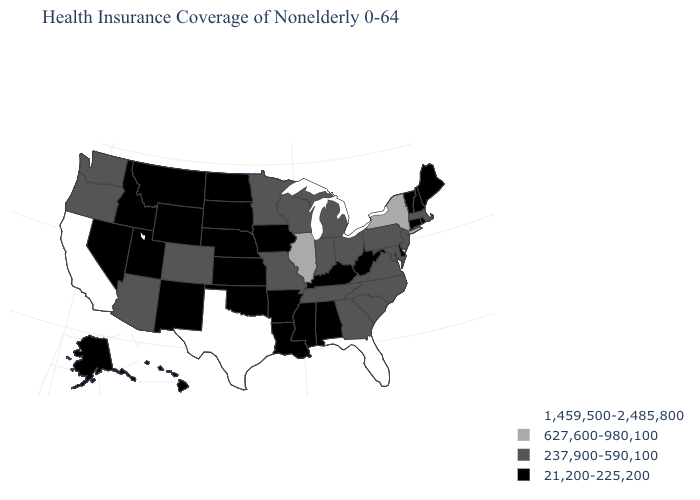Name the states that have a value in the range 237,900-590,100?
Answer briefly. Arizona, Colorado, Georgia, Indiana, Maryland, Massachusetts, Michigan, Minnesota, Missouri, New Jersey, North Carolina, Ohio, Oregon, Pennsylvania, South Carolina, Tennessee, Virginia, Washington, Wisconsin. Name the states that have a value in the range 627,600-980,100?
Write a very short answer. Illinois, New York. Does the first symbol in the legend represent the smallest category?
Keep it brief. No. Which states have the lowest value in the USA?
Keep it brief. Alabama, Alaska, Arkansas, Connecticut, Delaware, Hawaii, Idaho, Iowa, Kansas, Kentucky, Louisiana, Maine, Mississippi, Montana, Nebraska, Nevada, New Hampshire, New Mexico, North Dakota, Oklahoma, Rhode Island, South Dakota, Utah, Vermont, West Virginia, Wyoming. How many symbols are there in the legend?
Concise answer only. 4. Name the states that have a value in the range 627,600-980,100?
Give a very brief answer. Illinois, New York. Name the states that have a value in the range 237,900-590,100?
Answer briefly. Arizona, Colorado, Georgia, Indiana, Maryland, Massachusetts, Michigan, Minnesota, Missouri, New Jersey, North Carolina, Ohio, Oregon, Pennsylvania, South Carolina, Tennessee, Virginia, Washington, Wisconsin. What is the value of Mississippi?
Be succinct. 21,200-225,200. Name the states that have a value in the range 21,200-225,200?
Short answer required. Alabama, Alaska, Arkansas, Connecticut, Delaware, Hawaii, Idaho, Iowa, Kansas, Kentucky, Louisiana, Maine, Mississippi, Montana, Nebraska, Nevada, New Hampshire, New Mexico, North Dakota, Oklahoma, Rhode Island, South Dakota, Utah, Vermont, West Virginia, Wyoming. Name the states that have a value in the range 237,900-590,100?
Give a very brief answer. Arizona, Colorado, Georgia, Indiana, Maryland, Massachusetts, Michigan, Minnesota, Missouri, New Jersey, North Carolina, Ohio, Oregon, Pennsylvania, South Carolina, Tennessee, Virginia, Washington, Wisconsin. Does Hawaii have the lowest value in the USA?
Keep it brief. Yes. What is the value of Kentucky?
Keep it brief. 21,200-225,200. What is the lowest value in states that border Tennessee?
Give a very brief answer. 21,200-225,200. Name the states that have a value in the range 627,600-980,100?
Quick response, please. Illinois, New York. 